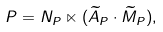<formula> <loc_0><loc_0><loc_500><loc_500>P = N _ { P } \ltimes ( \widetilde { A } _ { P } \cdot \widetilde { M } _ { P } ) ,</formula> 